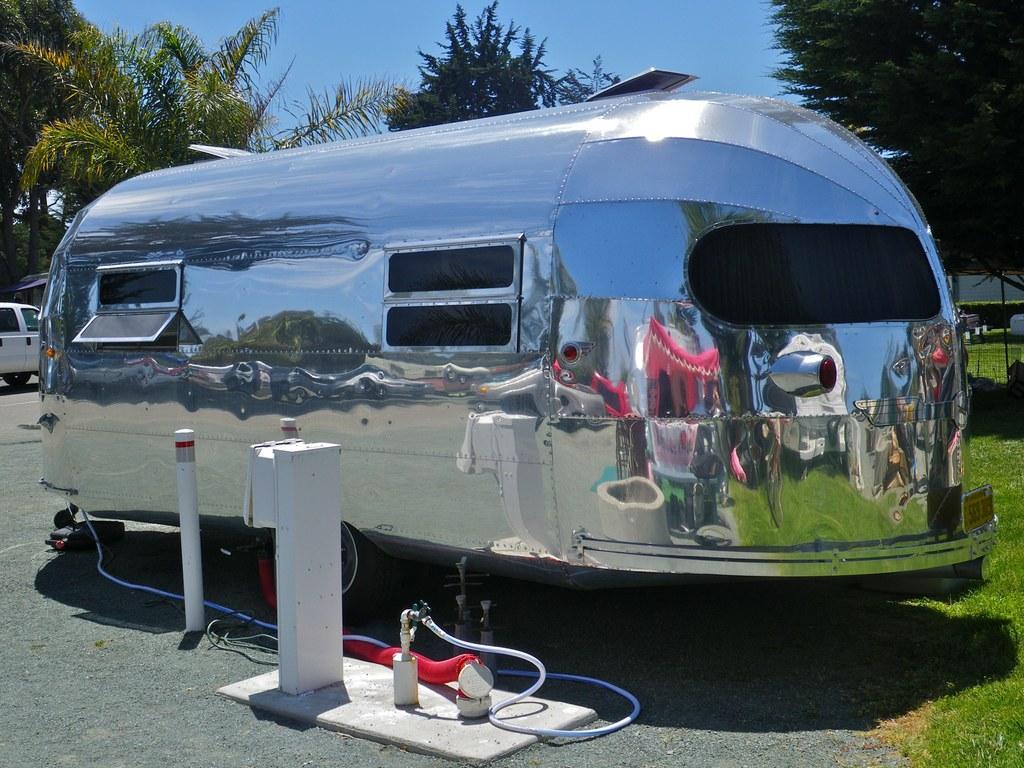In one or two sentences, can you explain what this image depicts? In this picture there is a travel trailer in the center of the image and there are plants at the top side of the image. 